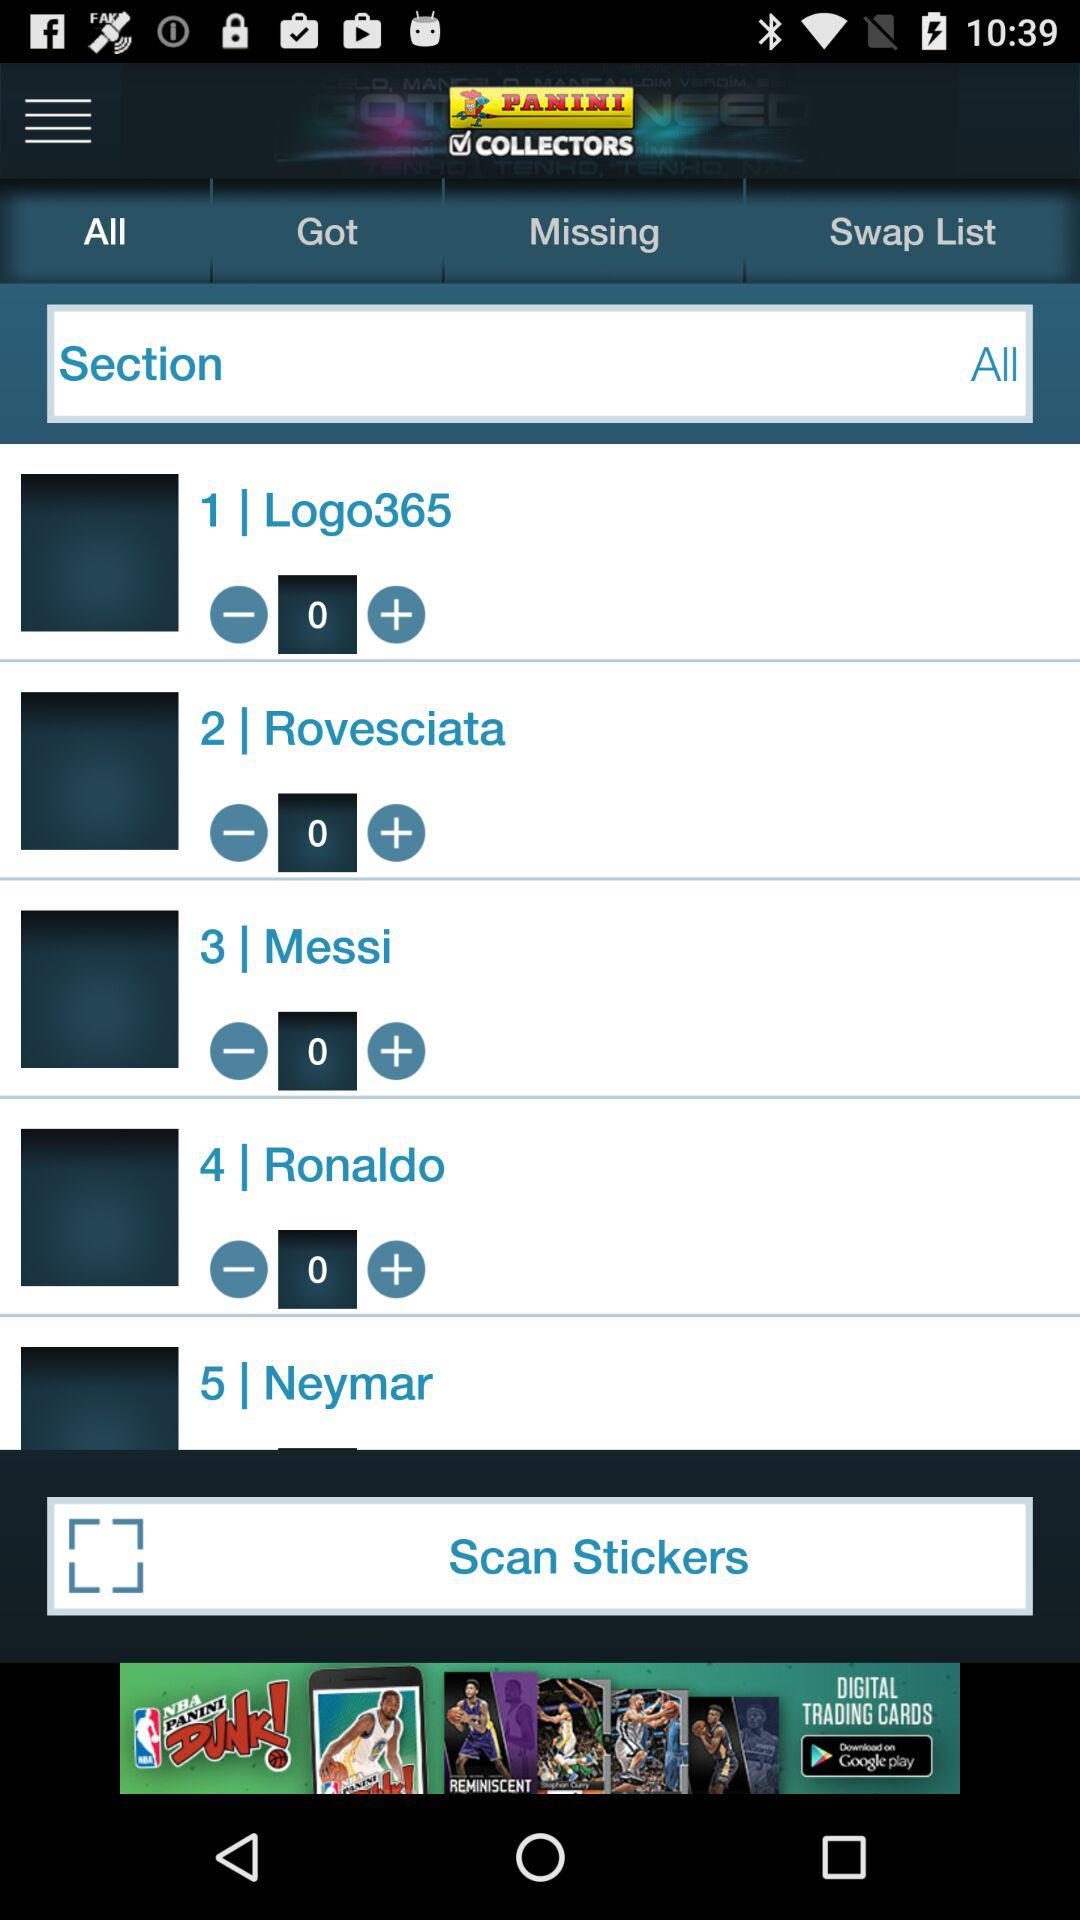How many stickers do I have in total?
Answer the question using a single word or phrase. 5 